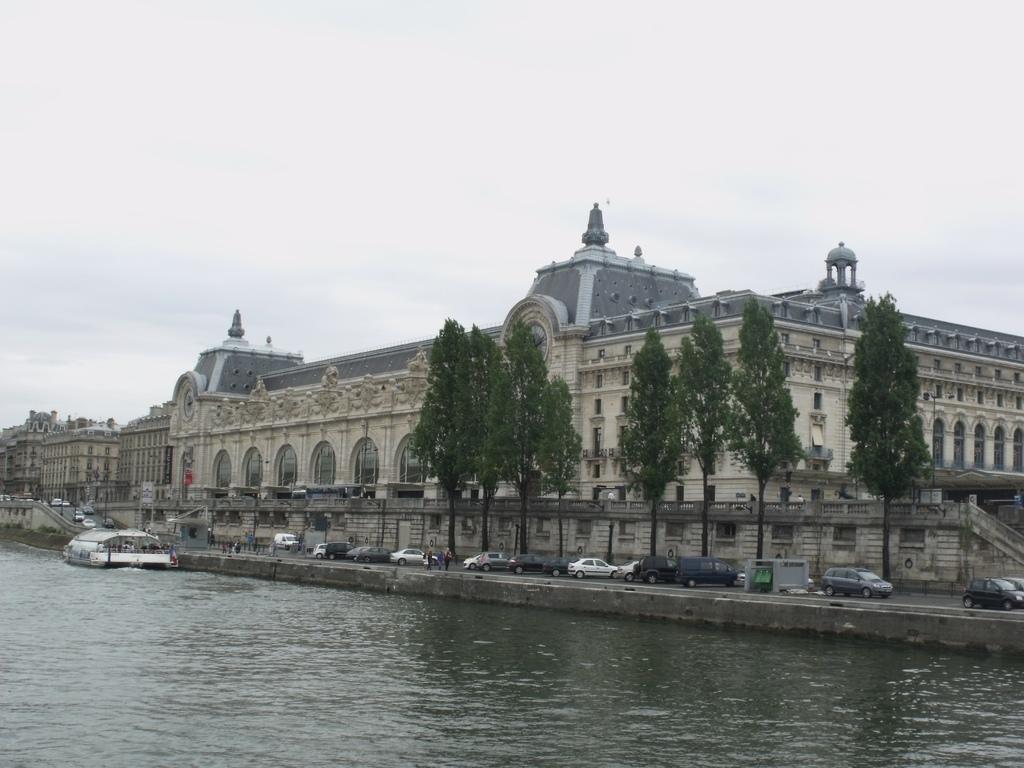In one or two sentences, can you explain what this image depicts? At the center of the image there are buildings, in front of the buildings there are trees and few cars are on the path and there is a boat on the river. In the background there is a sky. 